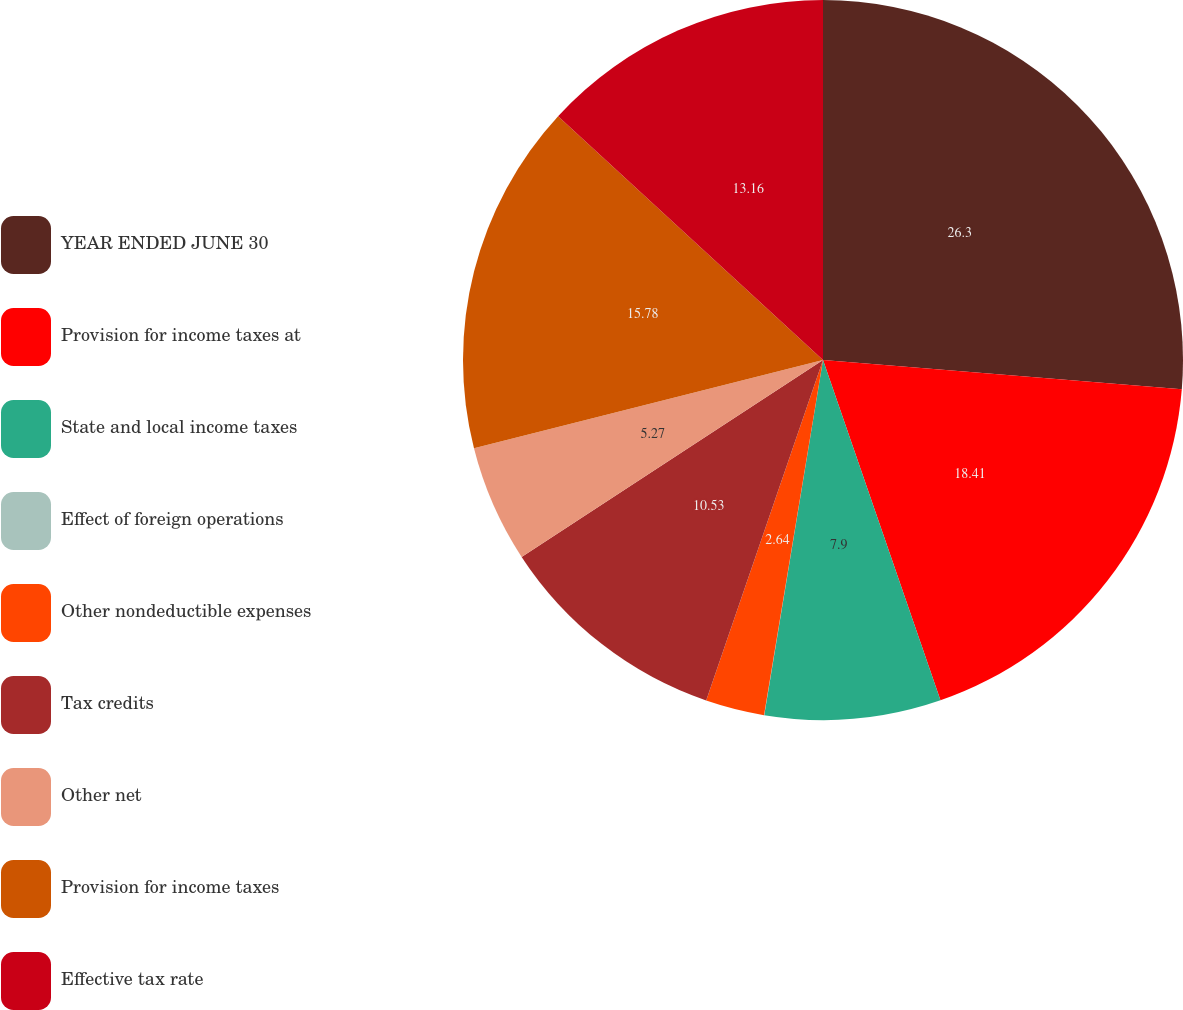<chart> <loc_0><loc_0><loc_500><loc_500><pie_chart><fcel>YEAR ENDED JUNE 30<fcel>Provision for income taxes at<fcel>State and local income taxes<fcel>Effect of foreign operations<fcel>Other nondeductible expenses<fcel>Tax credits<fcel>Other net<fcel>Provision for income taxes<fcel>Effective tax rate<nl><fcel>26.3%<fcel>18.41%<fcel>7.9%<fcel>0.01%<fcel>2.64%<fcel>10.53%<fcel>5.27%<fcel>15.78%<fcel>13.16%<nl></chart> 